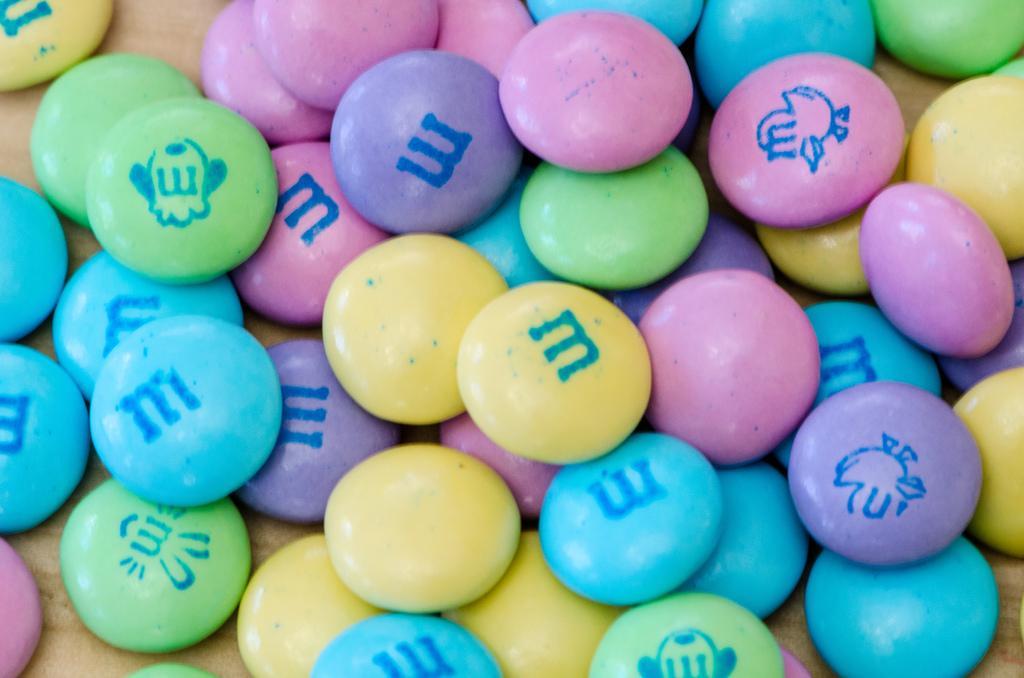Please provide a concise description of this image. In the picture I can see few gems which has something written on it is in different colors. 